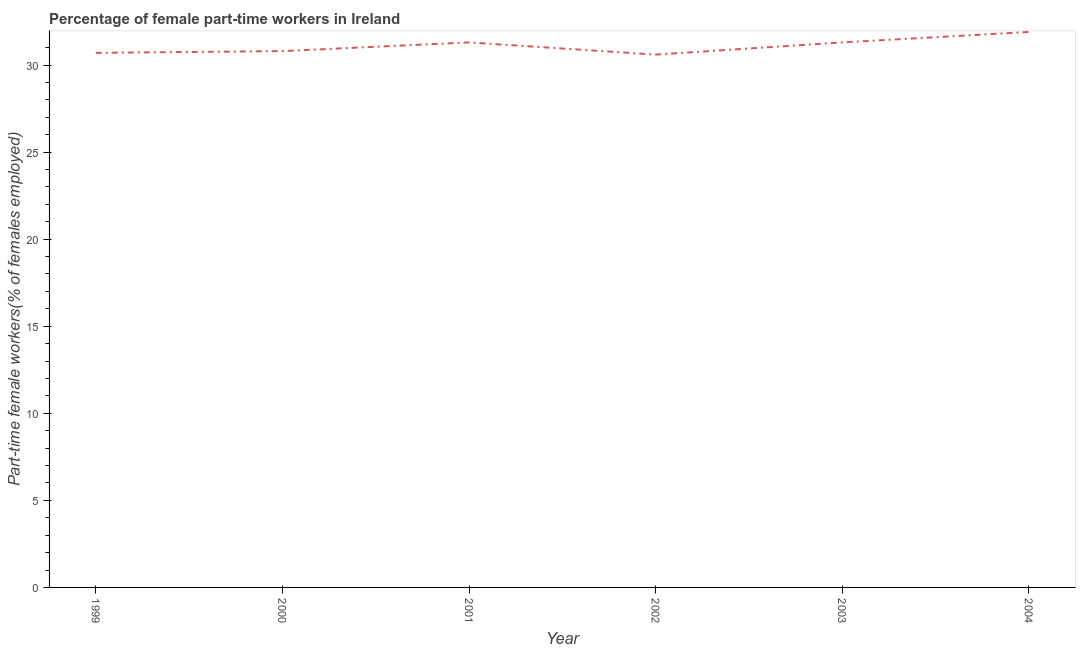What is the percentage of part-time female workers in 1999?
Ensure brevity in your answer.  30.7. Across all years, what is the maximum percentage of part-time female workers?
Provide a succinct answer. 31.9. Across all years, what is the minimum percentage of part-time female workers?
Provide a short and direct response. 30.6. In which year was the percentage of part-time female workers minimum?
Keep it short and to the point. 2002. What is the sum of the percentage of part-time female workers?
Provide a short and direct response. 186.6. What is the difference between the percentage of part-time female workers in 2002 and 2004?
Your answer should be very brief. -1.3. What is the average percentage of part-time female workers per year?
Provide a succinct answer. 31.1. What is the median percentage of part-time female workers?
Keep it short and to the point. 31.05. Do a majority of the years between 2004 and 2000 (inclusive) have percentage of part-time female workers greater than 3 %?
Offer a very short reply. Yes. What is the ratio of the percentage of part-time female workers in 2002 to that in 2004?
Your answer should be compact. 0.96. Is the percentage of part-time female workers in 1999 less than that in 2002?
Your response must be concise. No. What is the difference between the highest and the second highest percentage of part-time female workers?
Give a very brief answer. 0.6. What is the difference between the highest and the lowest percentage of part-time female workers?
Ensure brevity in your answer.  1.3. In how many years, is the percentage of part-time female workers greater than the average percentage of part-time female workers taken over all years?
Make the answer very short. 3. How many years are there in the graph?
Your response must be concise. 6. Are the values on the major ticks of Y-axis written in scientific E-notation?
Ensure brevity in your answer.  No. What is the title of the graph?
Make the answer very short. Percentage of female part-time workers in Ireland. What is the label or title of the X-axis?
Keep it short and to the point. Year. What is the label or title of the Y-axis?
Offer a very short reply. Part-time female workers(% of females employed). What is the Part-time female workers(% of females employed) in 1999?
Your answer should be compact. 30.7. What is the Part-time female workers(% of females employed) of 2000?
Make the answer very short. 30.8. What is the Part-time female workers(% of females employed) in 2001?
Make the answer very short. 31.3. What is the Part-time female workers(% of females employed) of 2002?
Ensure brevity in your answer.  30.6. What is the Part-time female workers(% of females employed) in 2003?
Your response must be concise. 31.3. What is the Part-time female workers(% of females employed) in 2004?
Give a very brief answer. 31.9. What is the difference between the Part-time female workers(% of females employed) in 1999 and 2003?
Provide a short and direct response. -0.6. What is the difference between the Part-time female workers(% of females employed) in 2000 and 2001?
Provide a succinct answer. -0.5. What is the difference between the Part-time female workers(% of females employed) in 2000 and 2003?
Provide a succinct answer. -0.5. What is the difference between the Part-time female workers(% of females employed) in 2001 and 2002?
Provide a succinct answer. 0.7. What is the ratio of the Part-time female workers(% of females employed) in 1999 to that in 2002?
Your answer should be compact. 1. What is the ratio of the Part-time female workers(% of females employed) in 2000 to that in 2001?
Make the answer very short. 0.98. What is the ratio of the Part-time female workers(% of females employed) in 2000 to that in 2003?
Offer a very short reply. 0.98. What is the ratio of the Part-time female workers(% of females employed) in 2000 to that in 2004?
Keep it short and to the point. 0.97. What is the ratio of the Part-time female workers(% of females employed) in 2001 to that in 2003?
Offer a very short reply. 1. What is the ratio of the Part-time female workers(% of females employed) in 2001 to that in 2004?
Your answer should be compact. 0.98. 